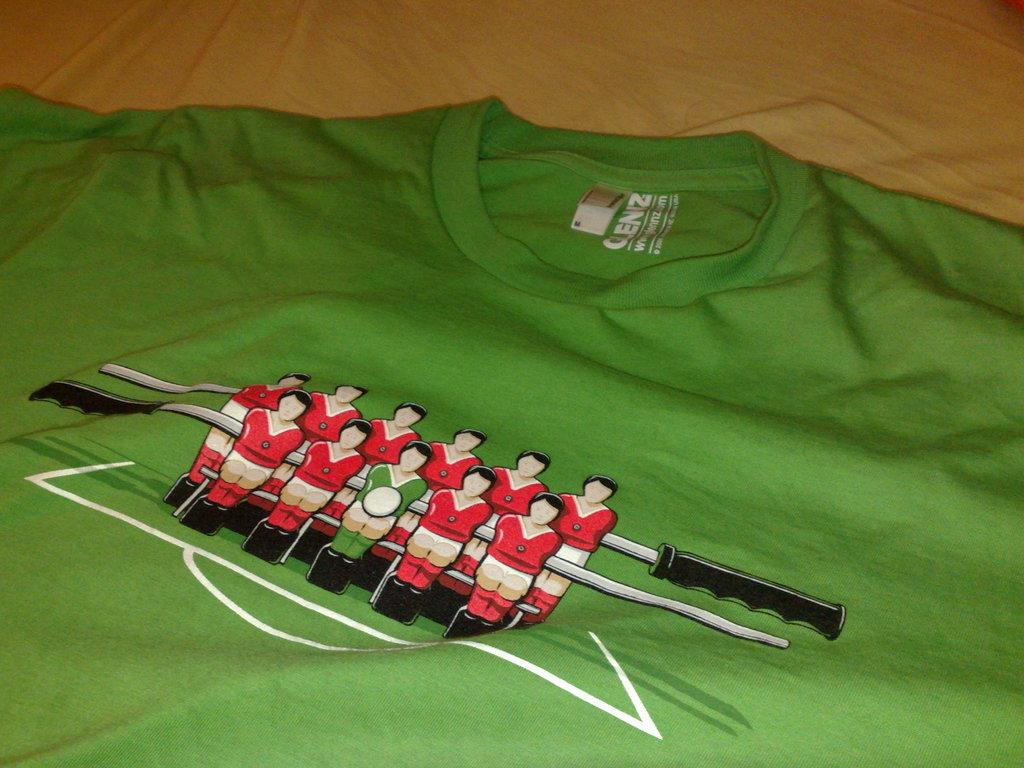What color is the T-shirt in the image? The T-shirt in the image is green. Where is the T-shirt located in the image? The T-shirt is placed on a bed. What type of birds can be seen flying in the image? There are no birds present in the image; it only features a green T-shirt on a bed. 